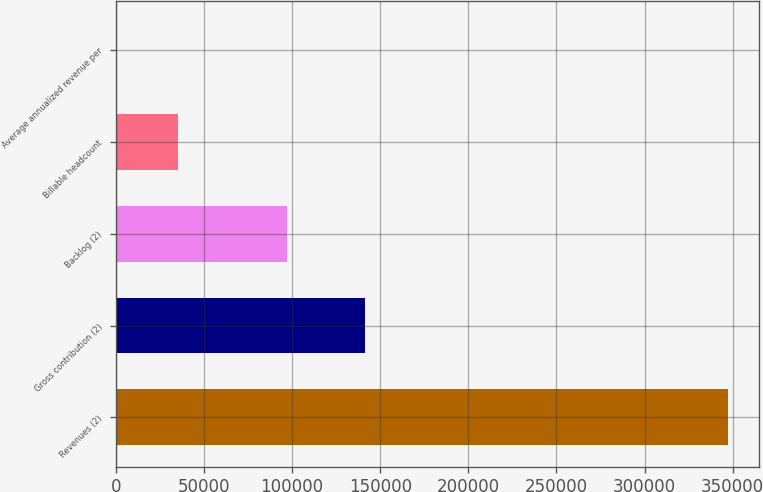Convert chart to OTSL. <chart><loc_0><loc_0><loc_500><loc_500><bar_chart><fcel>Revenues (2)<fcel>Gross contribution (2)<fcel>Backlog (2)<fcel>Billable headcount<fcel>Average annualized revenue per<nl><fcel>347404<fcel>141395<fcel>97169<fcel>35154.4<fcel>460<nl></chart> 